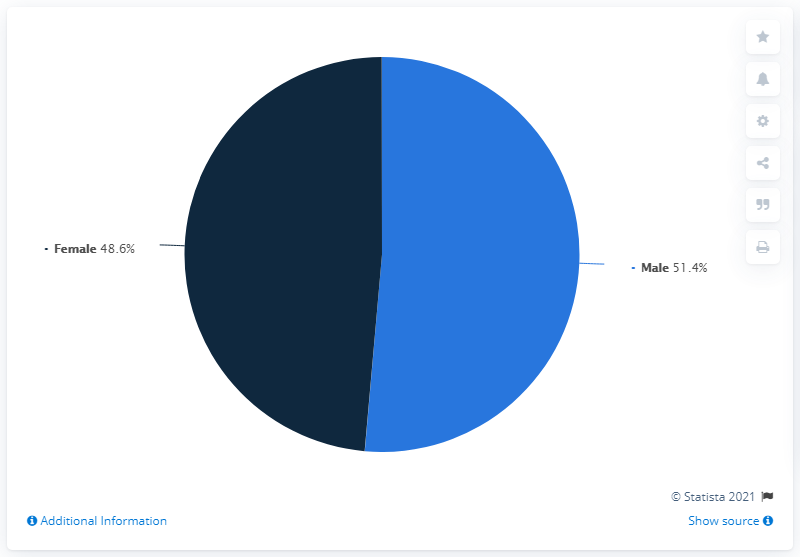Mention a couple of crucial points in this snapshot. The gender that has been heavily impacted is male. A total of 21,711 female patient samples were taken. 